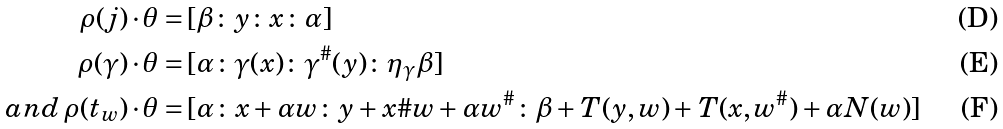Convert formula to latex. <formula><loc_0><loc_0><loc_500><loc_500>\rho ( j ) \cdot \theta = & \, [ \beta \colon y \colon x \colon \alpha ] \\ \rho ( \gamma ) \cdot \theta = & \, [ \alpha \colon \gamma ( x ) \colon \gamma ^ { \# } ( y ) \colon \eta _ { \gamma } \beta ] \\ a n d \, \rho ( t _ { w } ) \cdot \theta = & \, [ \alpha \colon x + \alpha w \colon y + x \# w + \alpha w ^ { \# } \colon \beta + T ( y , w ) + T ( x , w ^ { \# } ) + \alpha N ( w ) ]</formula> 